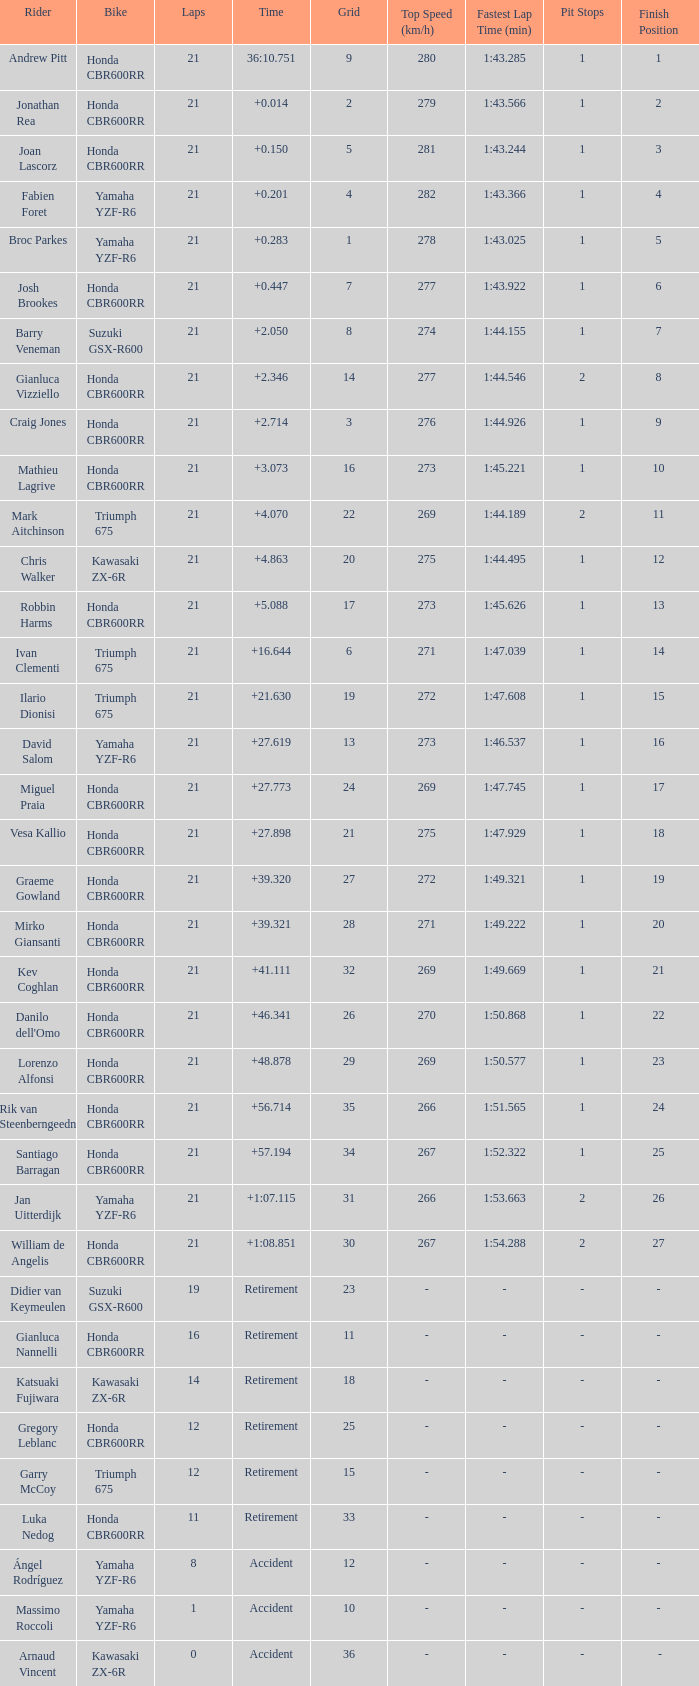What is the driver with the laps under 16, grid of 10, a bike of Yamaha YZF-R6, and ended with an accident? Massimo Roccoli. 